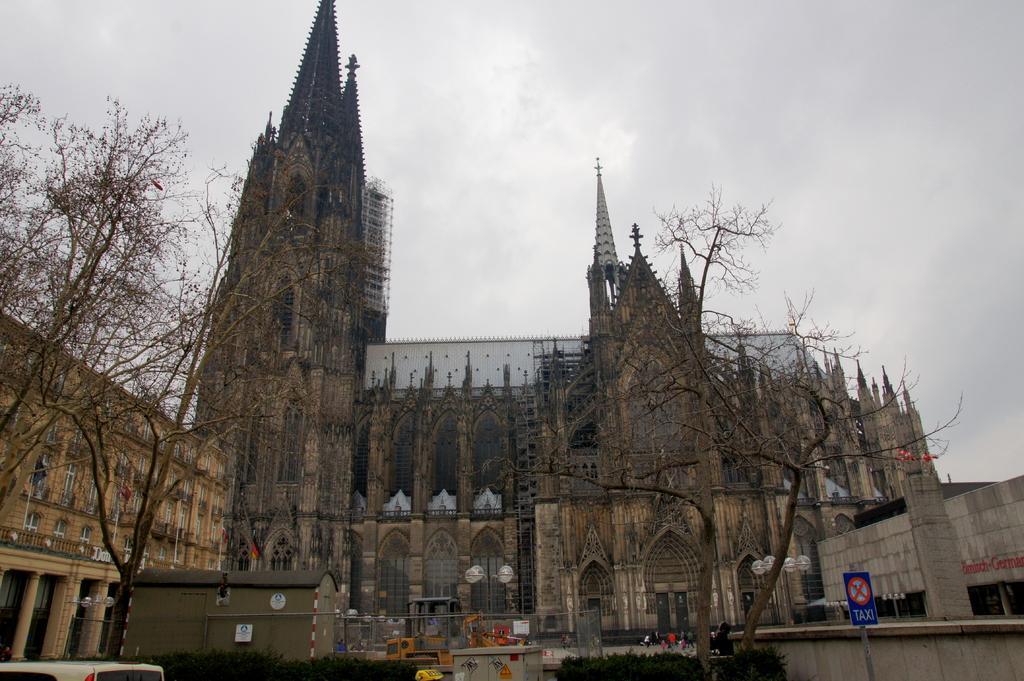Can you describe this image briefly? In this image we can see a big church and a building. There are many trees in the image. There is a vehicle at the left bottom most of the image. There is a sign board at the right bottom most of the image. 